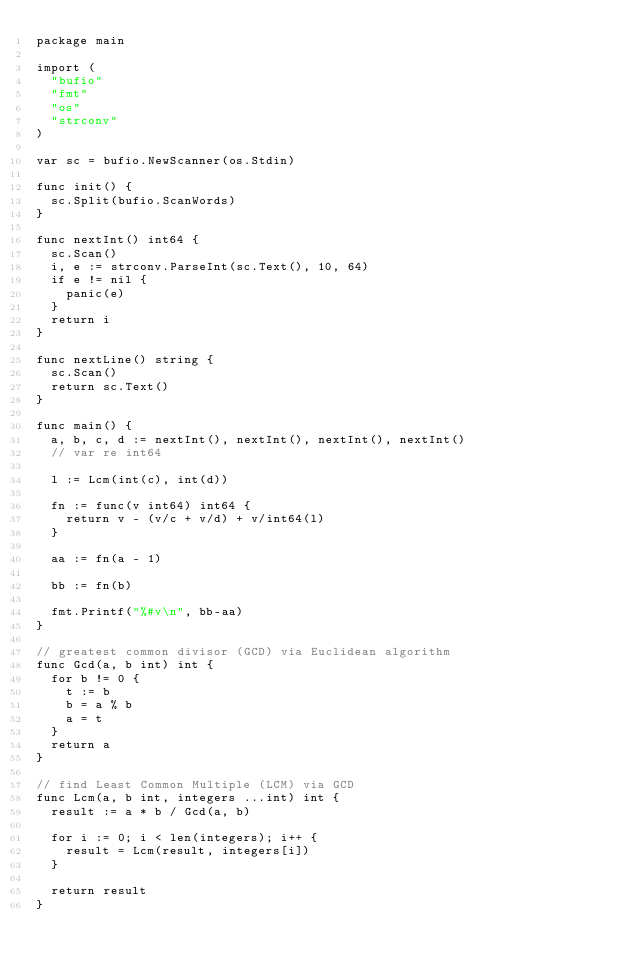<code> <loc_0><loc_0><loc_500><loc_500><_Go_>package main

import (
	"bufio"
	"fmt"
	"os"
	"strconv"
)

var sc = bufio.NewScanner(os.Stdin)

func init() {
	sc.Split(bufio.ScanWords)
}

func nextInt() int64 {
	sc.Scan()
	i, e := strconv.ParseInt(sc.Text(), 10, 64)
	if e != nil {
		panic(e)
	}
	return i
}

func nextLine() string {
	sc.Scan()
	return sc.Text()
}

func main() {
	a, b, c, d := nextInt(), nextInt(), nextInt(), nextInt()
	// var re int64

	l := Lcm(int(c), int(d))

	fn := func(v int64) int64 {
		return v - (v/c + v/d) + v/int64(l)
	}

	aa := fn(a - 1)

	bb := fn(b)

	fmt.Printf("%#v\n", bb-aa)
}

// greatest common divisor (GCD) via Euclidean algorithm
func Gcd(a, b int) int {
	for b != 0 {
		t := b
		b = a % b
		a = t
	}
	return a
}

// find Least Common Multiple (LCM) via GCD
func Lcm(a, b int, integers ...int) int {
	result := a * b / Gcd(a, b)

	for i := 0; i < len(integers); i++ {
		result = Lcm(result, integers[i])
	}

	return result
}
</code> 